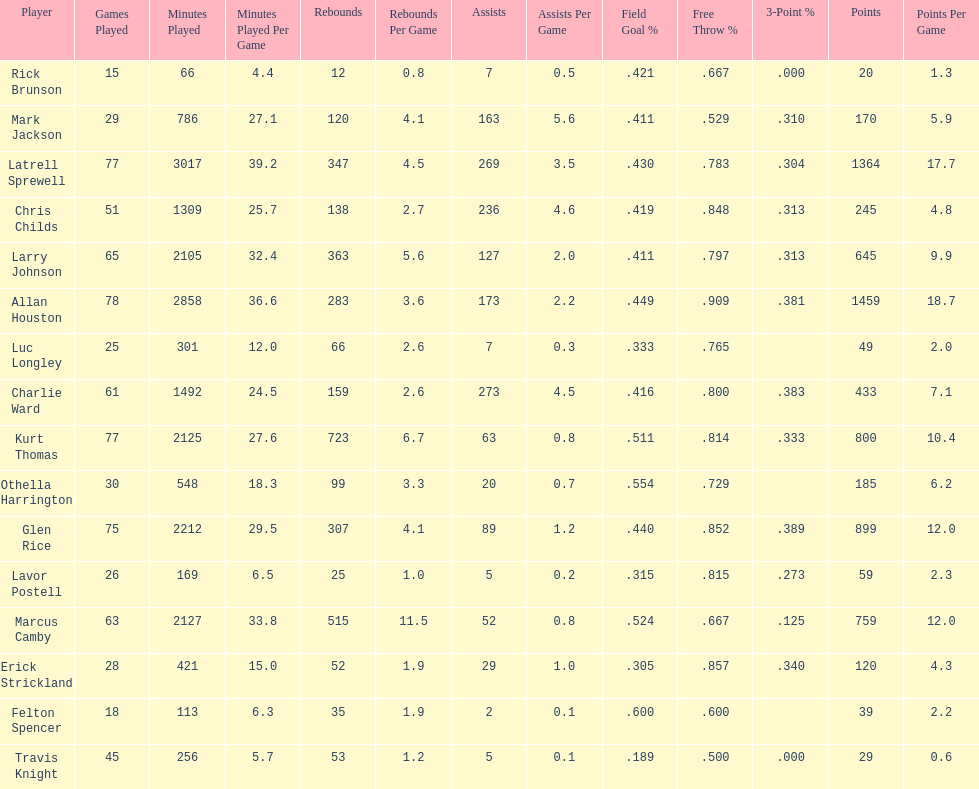How many more games did allan houston play than mark jackson? 49. Would you be able to parse every entry in this table? {'header': ['Player', 'Games Played', 'Minutes Played', 'Minutes Played Per Game', 'Rebounds', 'Rebounds Per Game', 'Assists', 'Assists Per Game', 'Field Goal\xa0%', 'Free Throw\xa0%', '3-Point\xa0%', 'Points', 'Points Per Game'], 'rows': [['Rick Brunson', '15', '66', '4.4', '12', '0.8', '7', '0.5', '.421', '.667', '.000', '20', '1.3'], ['Mark Jackson', '29', '786', '27.1', '120', '4.1', '163', '5.6', '.411', '.529', '.310', '170', '5.9'], ['Latrell Sprewell', '77', '3017', '39.2', '347', '4.5', '269', '3.5', '.430', '.783', '.304', '1364', '17.7'], ['Chris Childs', '51', '1309', '25.7', '138', '2.7', '236', '4.6', '.419', '.848', '.313', '245', '4.8'], ['Larry Johnson', '65', '2105', '32.4', '363', '5.6', '127', '2.0', '.411', '.797', '.313', '645', '9.9'], ['Allan Houston', '78', '2858', '36.6', '283', '3.6', '173', '2.2', '.449', '.909', '.381', '1459', '18.7'], ['Luc Longley', '25', '301', '12.0', '66', '2.6', '7', '0.3', '.333', '.765', '', '49', '2.0'], ['Charlie Ward', '61', '1492', '24.5', '159', '2.6', '273', '4.5', '.416', '.800', '.383', '433', '7.1'], ['Kurt Thomas', '77', '2125', '27.6', '723', '6.7', '63', '0.8', '.511', '.814', '.333', '800', '10.4'], ['Othella Harrington', '30', '548', '18.3', '99', '3.3', '20', '0.7', '.554', '.729', '', '185', '6.2'], ['Glen Rice', '75', '2212', '29.5', '307', '4.1', '89', '1.2', '.440', '.852', '.389', '899', '12.0'], ['Lavor Postell', '26', '169', '6.5', '25', '1.0', '5', '0.2', '.315', '.815', '.273', '59', '2.3'], ['Marcus Camby', '63', '2127', '33.8', '515', '11.5', '52', '0.8', '.524', '.667', '.125', '759', '12.0'], ['Erick Strickland', '28', '421', '15.0', '52', '1.9', '29', '1.0', '.305', '.857', '.340', '120', '4.3'], ['Felton Spencer', '18', '113', '6.3', '35', '1.9', '2', '0.1', '.600', '.600', '', '39', '2.2'], ['Travis Knight', '45', '256', '5.7', '53', '1.2', '5', '0.1', '.189', '.500', '.000', '29', '0.6']]} 